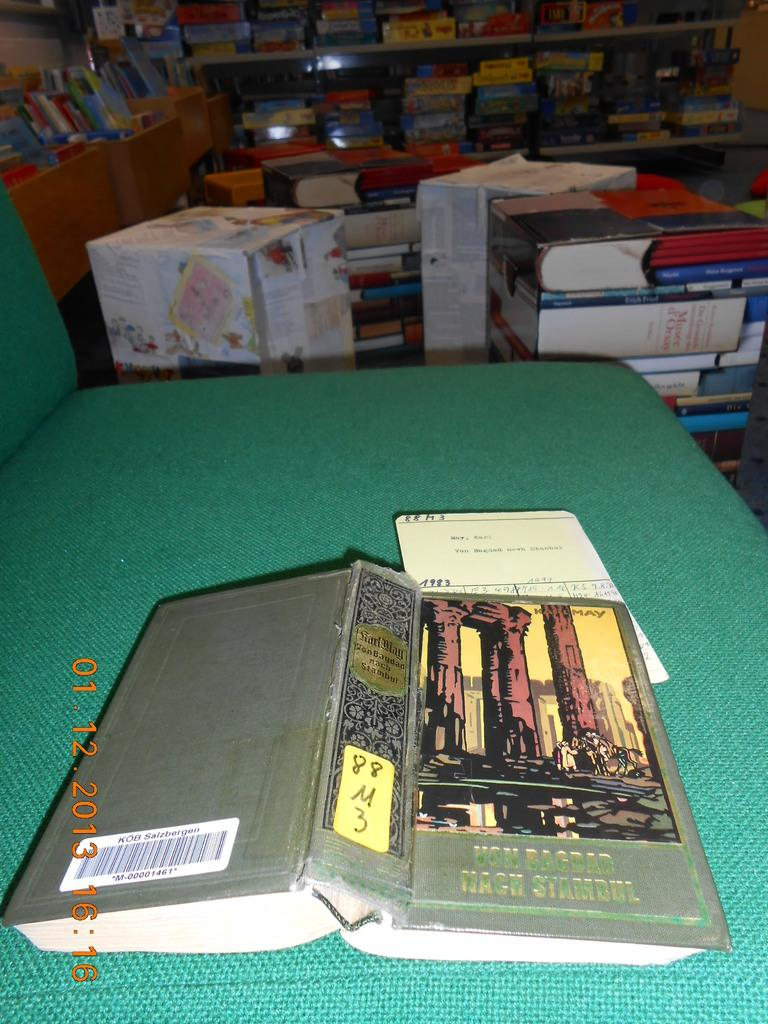<image>
Write a terse but informative summary of the picture. A picture of a book called Uom Bagdad Mach Stambul was taken in 2013 